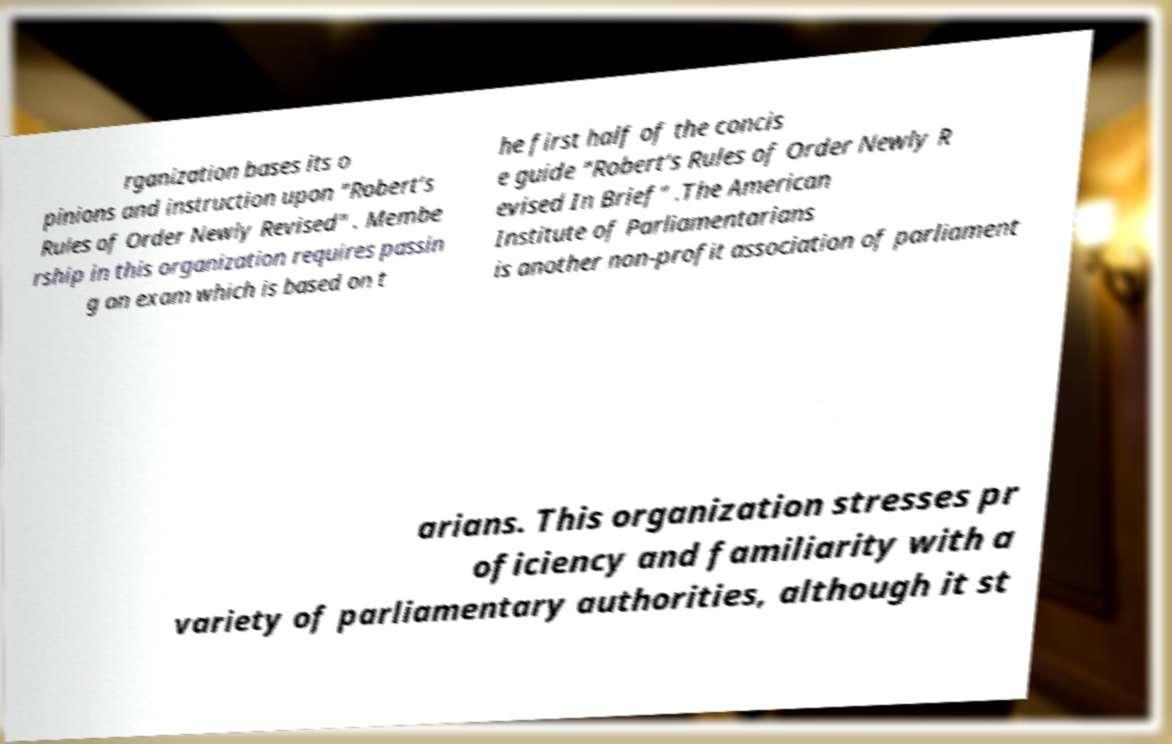There's text embedded in this image that I need extracted. Can you transcribe it verbatim? rganization bases its o pinions and instruction upon "Robert’s Rules of Order Newly Revised" . Membe rship in this organization requires passin g an exam which is based on t he first half of the concis e guide "Robert’s Rules of Order Newly R evised In Brief" .The American Institute of Parliamentarians is another non-profit association of parliament arians. This organization stresses pr oficiency and familiarity with a variety of parliamentary authorities, although it st 